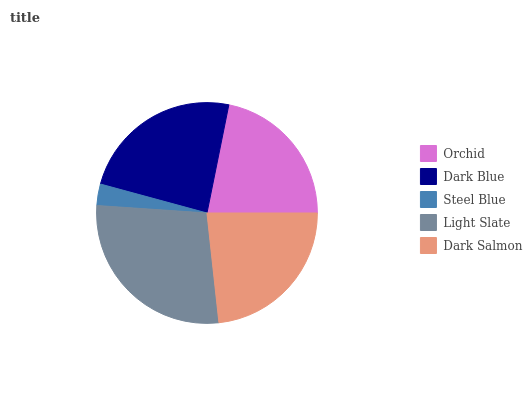Is Steel Blue the minimum?
Answer yes or no. Yes. Is Light Slate the maximum?
Answer yes or no. Yes. Is Dark Blue the minimum?
Answer yes or no. No. Is Dark Blue the maximum?
Answer yes or no. No. Is Dark Blue greater than Orchid?
Answer yes or no. Yes. Is Orchid less than Dark Blue?
Answer yes or no. Yes. Is Orchid greater than Dark Blue?
Answer yes or no. No. Is Dark Blue less than Orchid?
Answer yes or no. No. Is Dark Salmon the high median?
Answer yes or no. Yes. Is Dark Salmon the low median?
Answer yes or no. Yes. Is Orchid the high median?
Answer yes or no. No. Is Steel Blue the low median?
Answer yes or no. No. 